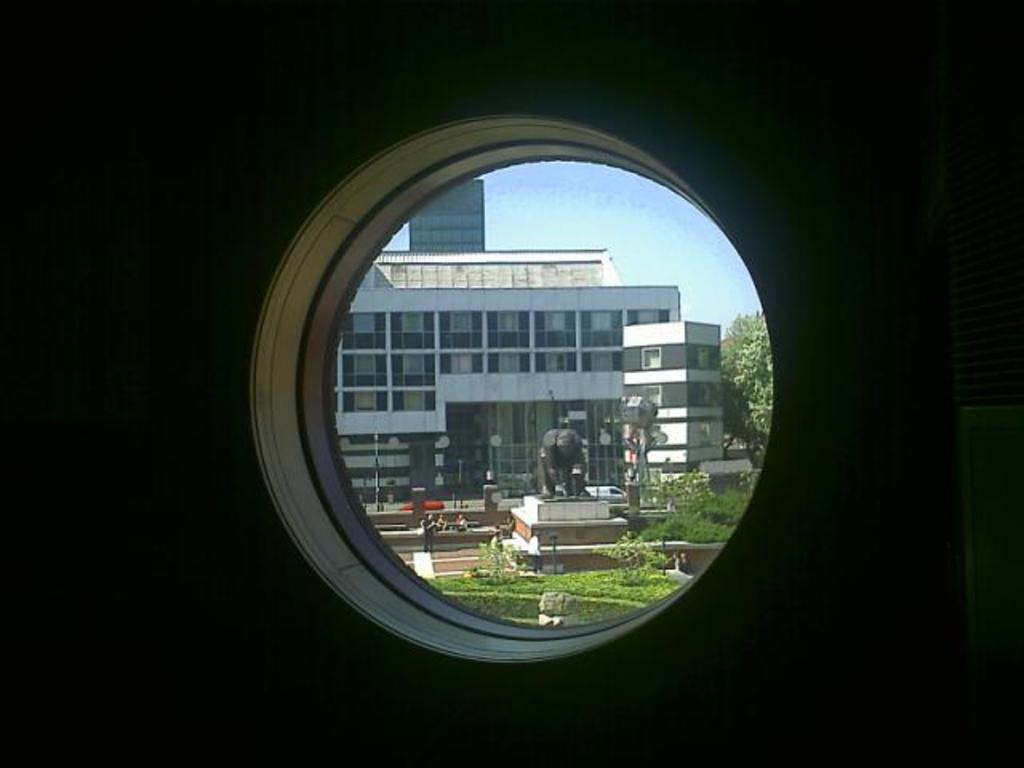What type of window is present in the image? There is a glass window in the image. What can be seen through the glass window? A building, a statue, trees, grass, people, poles, and the sky are visible through the glass window. Are there any other objects visible behind the glass window? Yes, there are other objects visible behind the glass window. What date is marked on the calendar visible in the image? There is no calendar present in the image. What time is indicated on the alarm clock visible in the image? There is no alarm clock present in the image. 